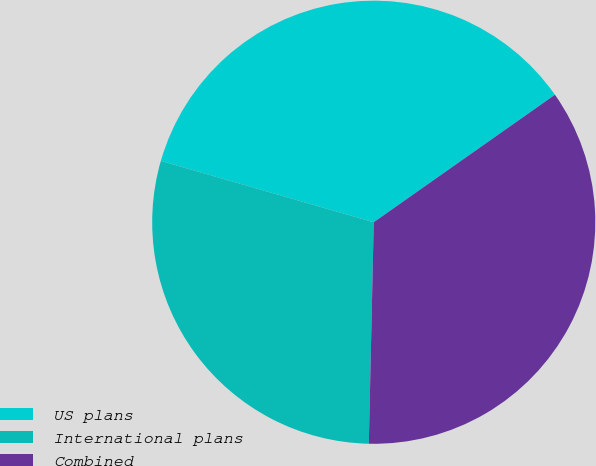Convert chart to OTSL. <chart><loc_0><loc_0><loc_500><loc_500><pie_chart><fcel>US plans<fcel>International plans<fcel>Combined<nl><fcel>35.78%<fcel>29.11%<fcel>35.11%<nl></chart> 